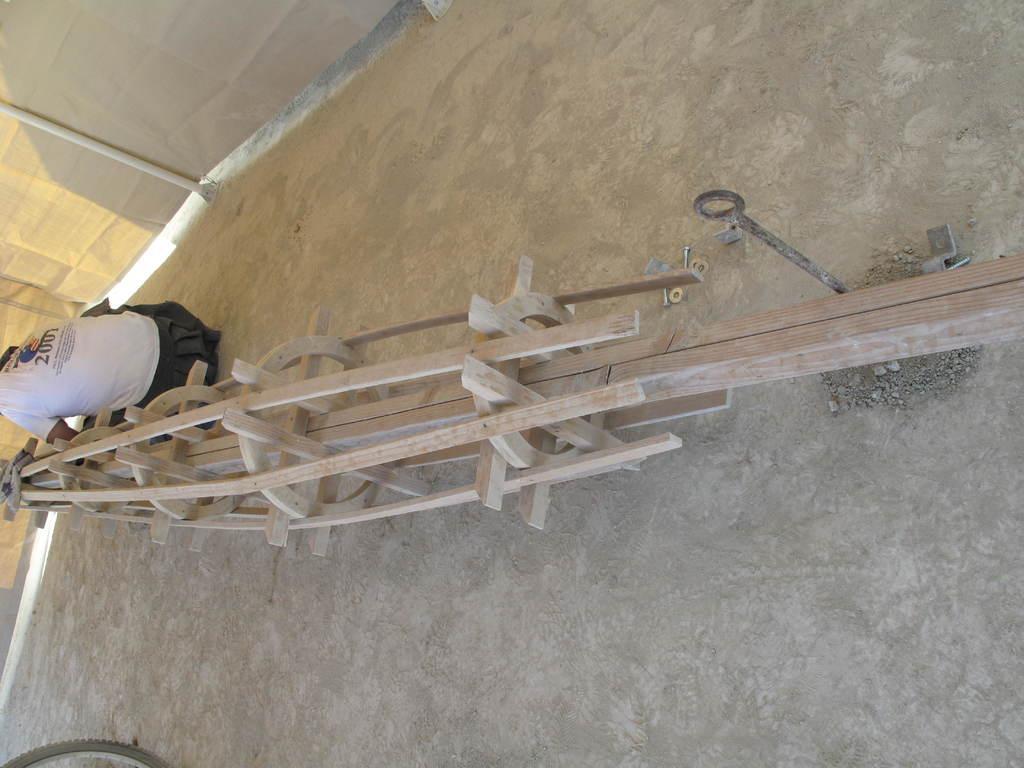In one or two sentences, can you explain what this image depicts? In the center of the image there is a wooden object. Beside the object there is a person sitting on the ground. In the background of the image there are curtains. 